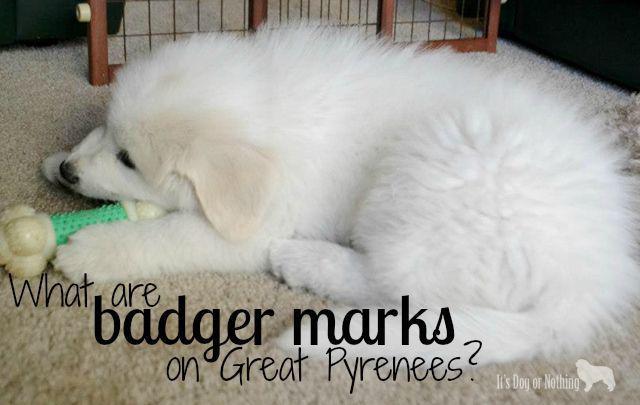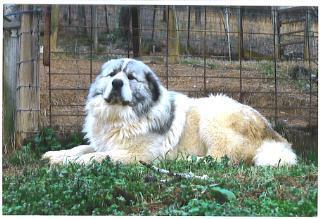The first image is the image on the left, the second image is the image on the right. Evaluate the accuracy of this statement regarding the images: "Each image shows one young puppy, and at least one image shows a brown-eared puppy reclining with its front paws forward.". Is it true? Answer yes or no. No. The first image is the image on the left, the second image is the image on the right. Evaluate the accuracy of this statement regarding the images: "One of the images features an adult dog on green grass.". Is it true? Answer yes or no. Yes. 